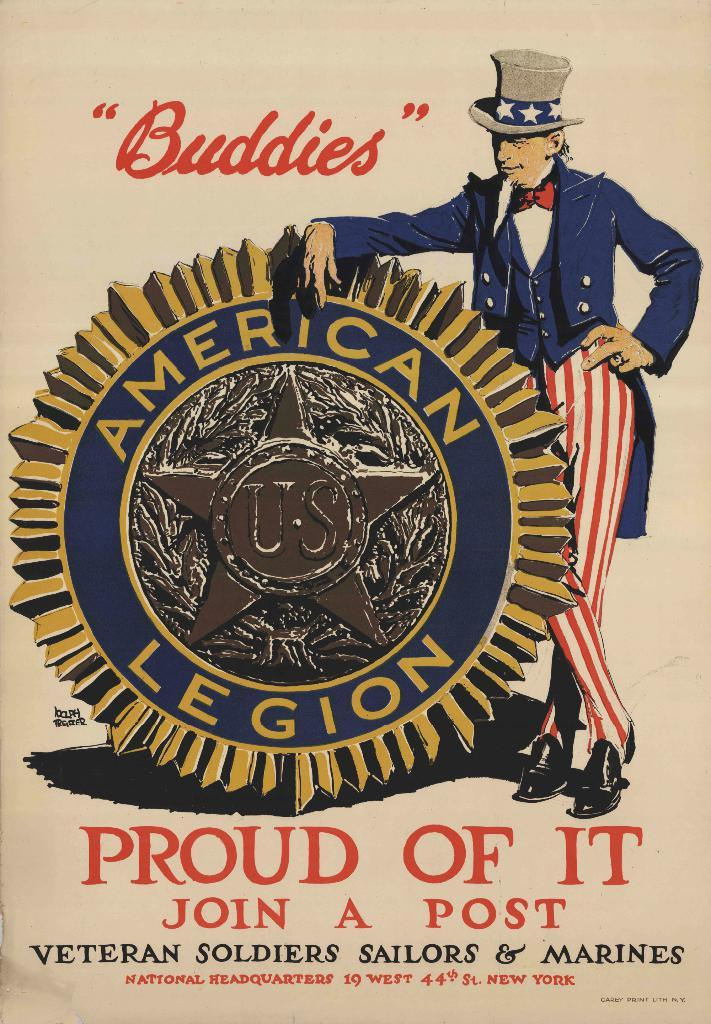<image>
Give a short and clear explanation of the subsequent image. The sign features a patriotic man next to an emblem that reads American Legion. 